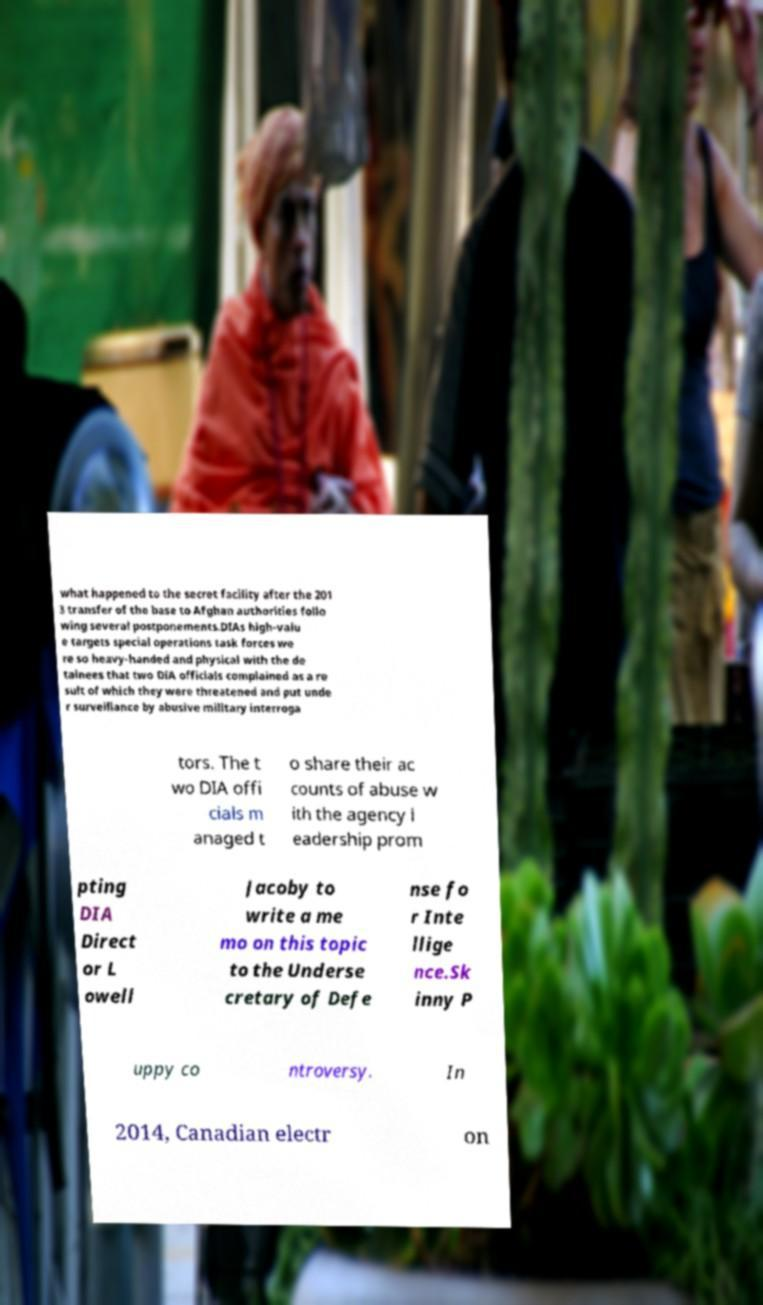Please identify and transcribe the text found in this image. what happened to the secret facility after the 201 3 transfer of the base to Afghan authorities follo wing several postponements.DIAs high-valu e targets special operations task forces we re so heavy-handed and physical with the de tainees that two DIA officials complained as a re sult of which they were threatened and put unde r surveillance by abusive military interroga tors. The t wo DIA offi cials m anaged t o share their ac counts of abuse w ith the agency l eadership prom pting DIA Direct or L owell Jacoby to write a me mo on this topic to the Underse cretary of Defe nse fo r Inte llige nce.Sk inny P uppy co ntroversy. In 2014, Canadian electr on 